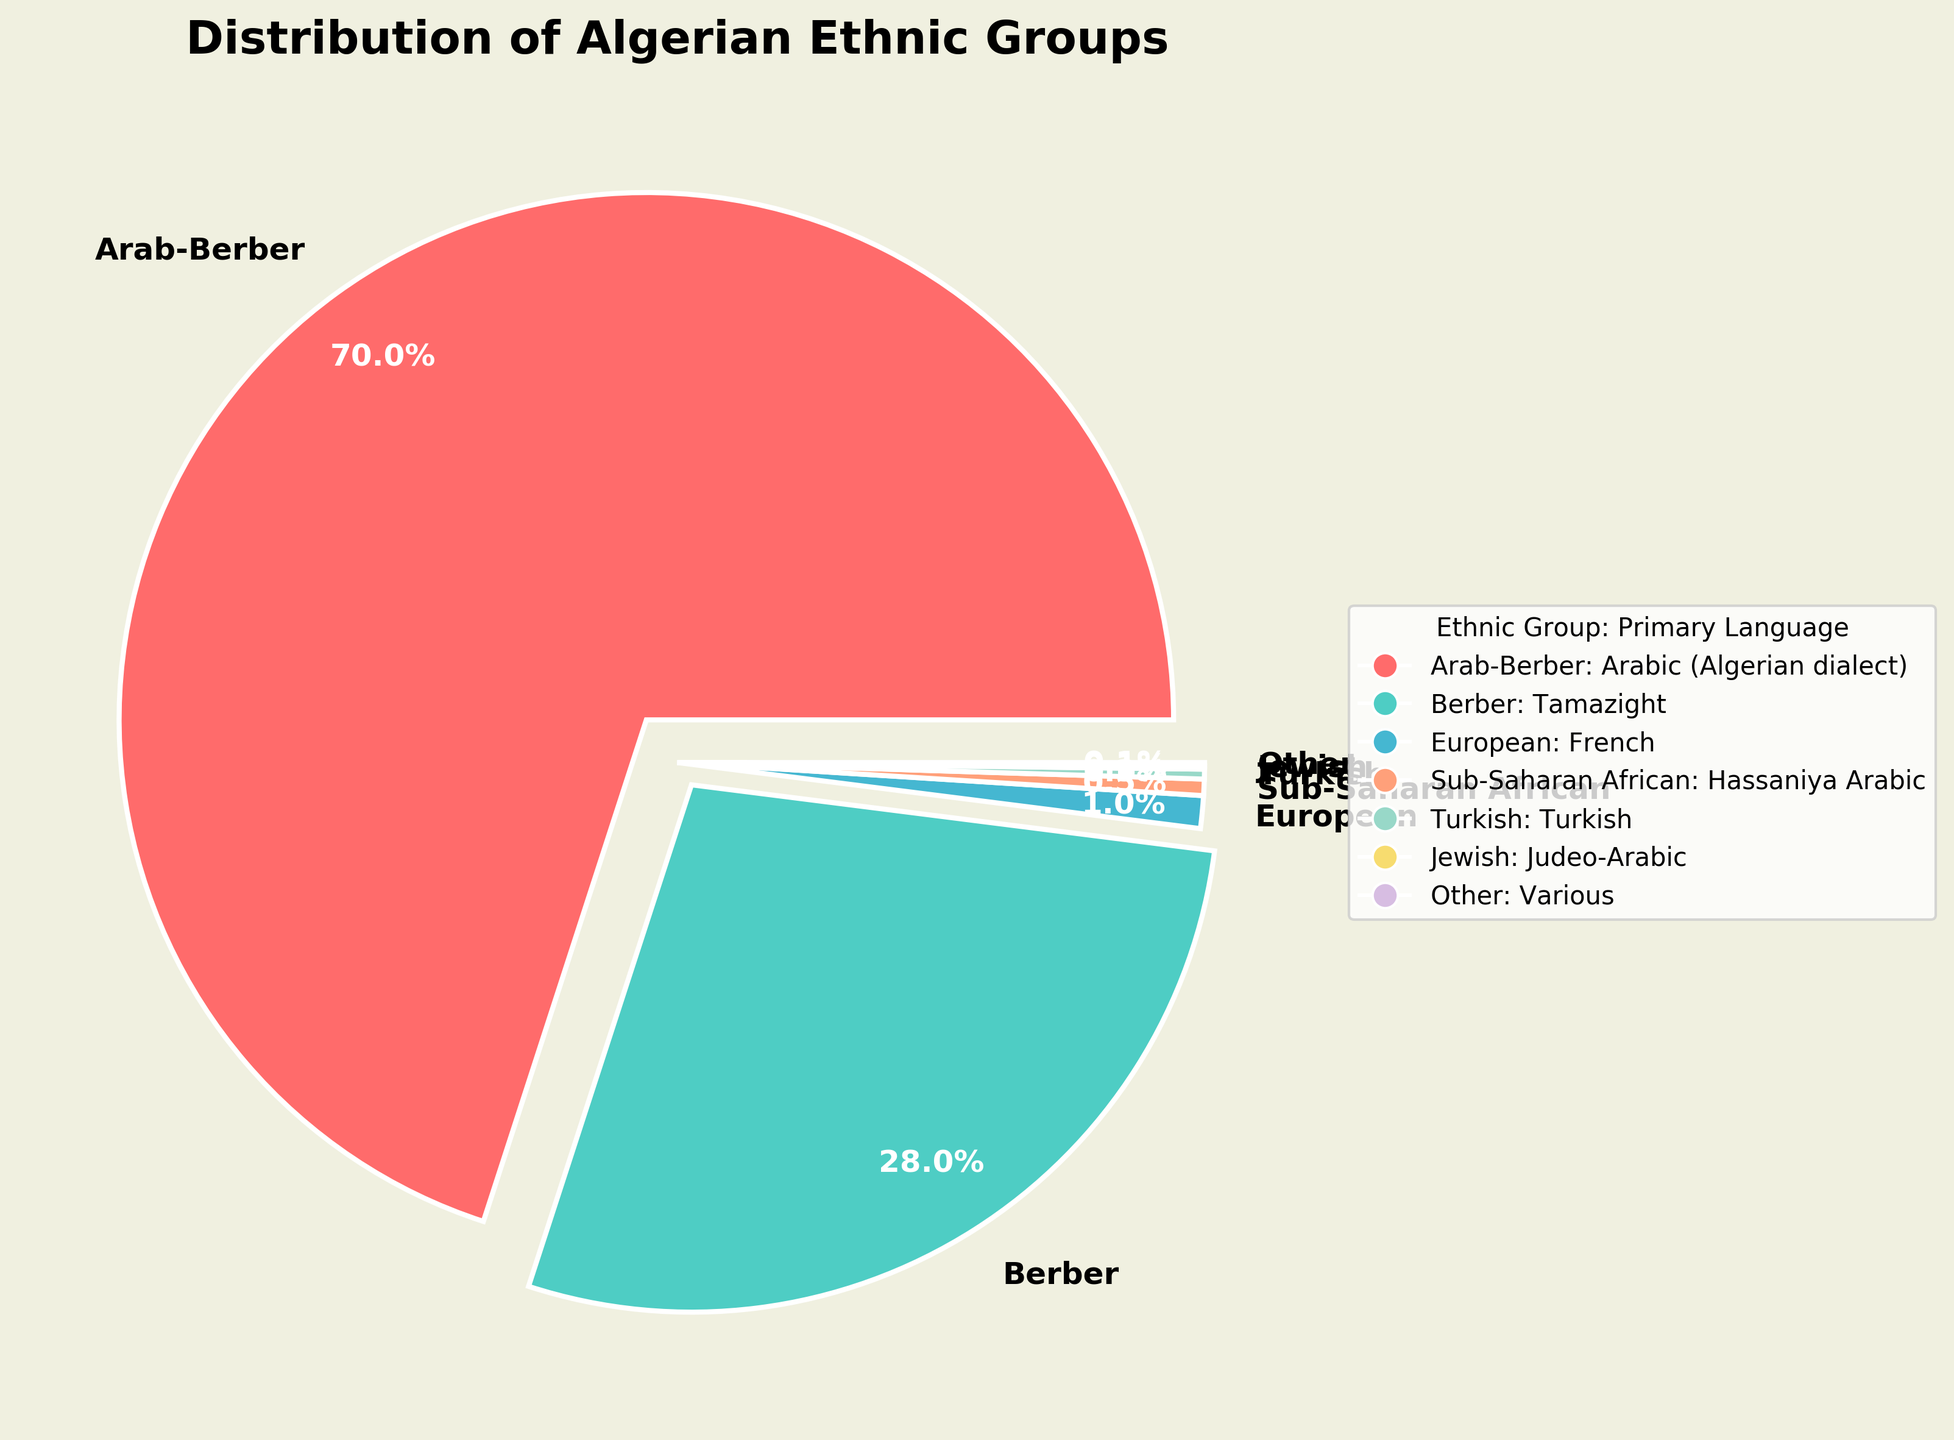What is the largest ethnic group percentage in Algeria? The chart shows that the Arab-Berber group has the largest wedge size and the label indicates it constitutes 70% of the population. Thus, the largest ethnic group is Arab-Berber with 70%.
Answer: Arab-Berber with 70% Which two ethnic groups combined make up nearly the entire population of Algeria? From the pie chart, the Arab-Berber (70%) and Berber (28%) groups have the largest sections. Together, they make up 70% + 28% = 98% of the population.
Answer: Arab-Berber and Berber How much more is the percentage of Arab-Berber compared to European? The Arab-Berber percentage is 70%, and the European percentage is 1%. The difference is 70% - 1% = 69%.
Answer: 69% What color represents the Turkish ethnic group in the pie chart? By referring to the legend, the Turkish ethnic group is associated with a light purple color.
Answer: Light purple What percentage of the population does the Sub-Saharan African group represent? The label on the pie chart wedge corresponding to Sub-Saharan African indicates 0.5%.
Answer: 0.5% Which ethnic group is represented with the least percentage and what language do they primarily speak? From the chart, the Jewish and Other groups both have the least percentage at 0.1%. The Jewish group primarily speaks Judeo-Arabic.
Answer: Jewish and Various Is the combined percentage of the European and Sub-Saharan African groups more than 1.5%? The European group has 1% and the Sub-Saharan African has 0.5%. Combined, they represent 1% + 0.5% = 1.5%, so it is not more than 1.5%.
Answer: No What primary language is spoken by the group that constitutes 0.3% of the population? According to the pie chart, the Turkish group constitutes 0.3% of the population and speaks Turkish.
Answer: Turkish Between the Berber and Sub-Saharan African groups, which one has a larger population percentage and by how much? The Berber group accounts for 28%, while the Sub-Saharan African group accounts for 0.5%. The difference is 28% - 0.5% = 27.5%.
Answer: Berber by 27.5% 